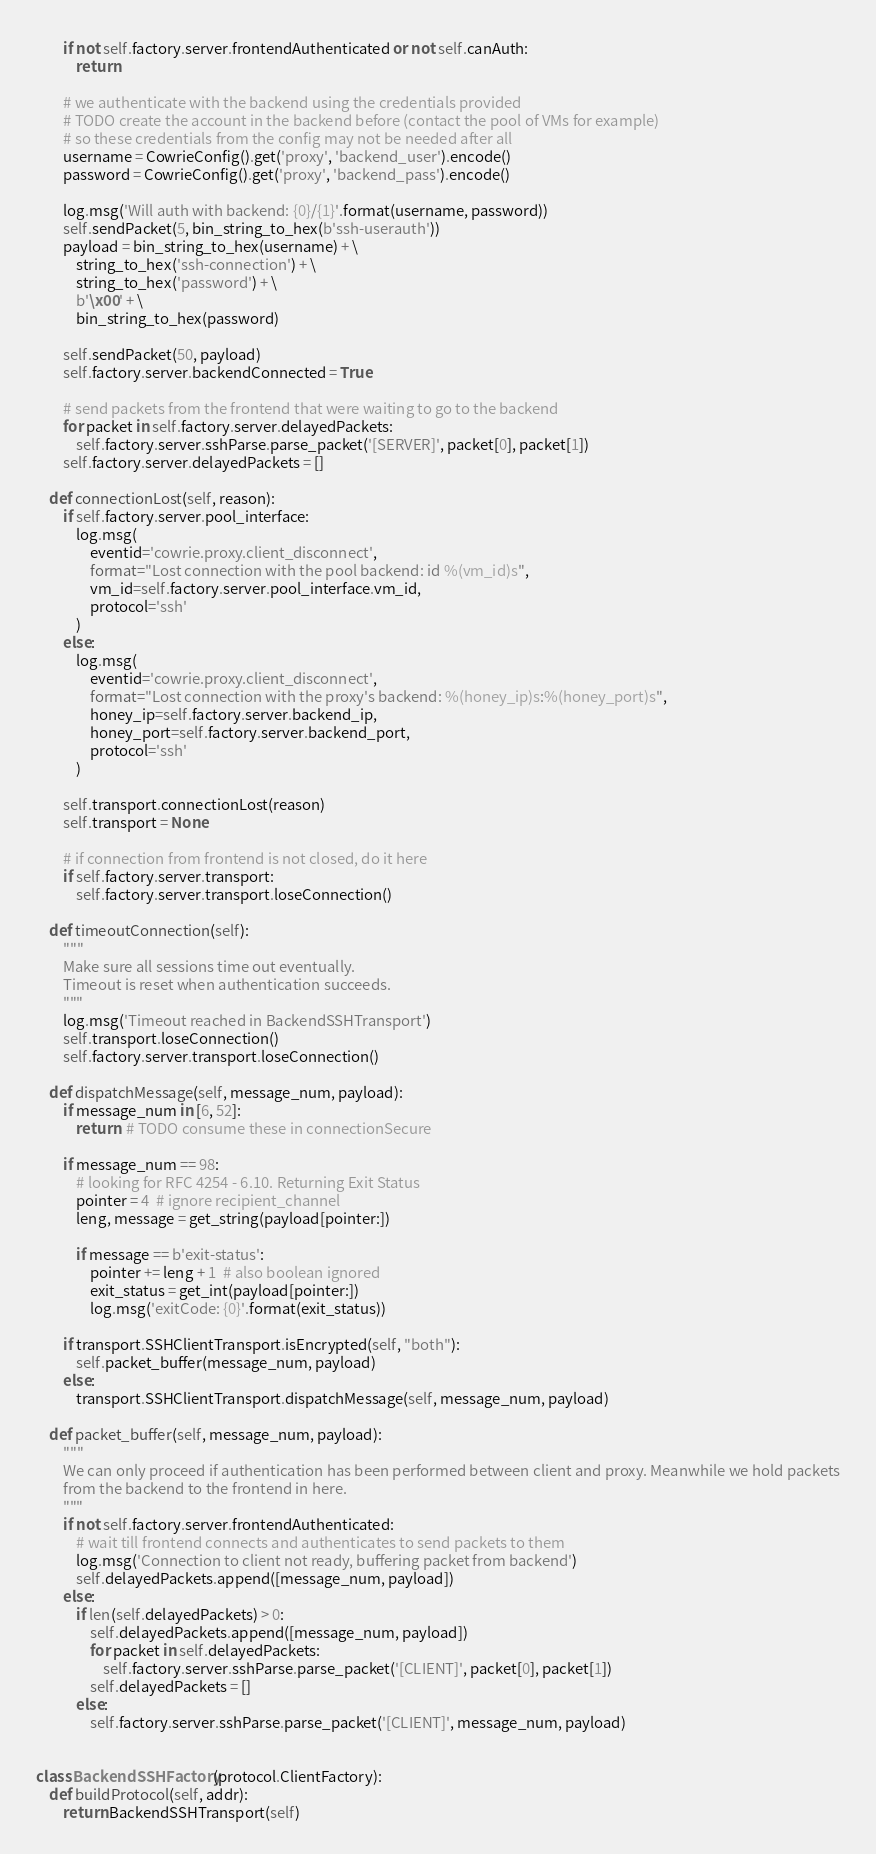Convert code to text. <code><loc_0><loc_0><loc_500><loc_500><_Python_>        if not self.factory.server.frontendAuthenticated or not self.canAuth:
            return

        # we authenticate with the backend using the credentials provided
        # TODO create the account in the backend before (contact the pool of VMs for example)
        # so these credentials from the config may not be needed after all
        username = CowrieConfig().get('proxy', 'backend_user').encode()
        password = CowrieConfig().get('proxy', 'backend_pass').encode()

        log.msg('Will auth with backend: {0}/{1}'.format(username, password))
        self.sendPacket(5, bin_string_to_hex(b'ssh-userauth'))
        payload = bin_string_to_hex(username) + \
            string_to_hex('ssh-connection') + \
            string_to_hex('password') + \
            b'\x00' + \
            bin_string_to_hex(password)

        self.sendPacket(50, payload)
        self.factory.server.backendConnected = True

        # send packets from the frontend that were waiting to go to the backend
        for packet in self.factory.server.delayedPackets:
            self.factory.server.sshParse.parse_packet('[SERVER]', packet[0], packet[1])
        self.factory.server.delayedPackets = []

    def connectionLost(self, reason):
        if self.factory.server.pool_interface:
            log.msg(
                eventid='cowrie.proxy.client_disconnect',
                format="Lost connection with the pool backend: id %(vm_id)s",
                vm_id=self.factory.server.pool_interface.vm_id,
                protocol='ssh'
            )
        else:
            log.msg(
                eventid='cowrie.proxy.client_disconnect',
                format="Lost connection with the proxy's backend: %(honey_ip)s:%(honey_port)s",
                honey_ip=self.factory.server.backend_ip,
                honey_port=self.factory.server.backend_port,
                protocol='ssh'
            )

        self.transport.connectionLost(reason)
        self.transport = None

        # if connection from frontend is not closed, do it here
        if self.factory.server.transport:
            self.factory.server.transport.loseConnection()

    def timeoutConnection(self):
        """
        Make sure all sessions time out eventually.
        Timeout is reset when authentication succeeds.
        """
        log.msg('Timeout reached in BackendSSHTransport')
        self.transport.loseConnection()
        self.factory.server.transport.loseConnection()

    def dispatchMessage(self, message_num, payload):
        if message_num in [6, 52]:
            return  # TODO consume these in connectionSecure

        if message_num == 98:
            # looking for RFC 4254 - 6.10. Returning Exit Status
            pointer = 4  # ignore recipient_channel
            leng, message = get_string(payload[pointer:])

            if message == b'exit-status':
                pointer += leng + 1  # also boolean ignored
                exit_status = get_int(payload[pointer:])
                log.msg('exitCode: {0}'.format(exit_status))

        if transport.SSHClientTransport.isEncrypted(self, "both"):
            self.packet_buffer(message_num, payload)
        else:
            transport.SSHClientTransport.dispatchMessage(self, message_num, payload)

    def packet_buffer(self, message_num, payload):
        """
        We can only proceed if authentication has been performed between client and proxy. Meanwhile we hold packets
        from the backend to the frontend in here.
        """
        if not self.factory.server.frontendAuthenticated:
            # wait till frontend connects and authenticates to send packets to them
            log.msg('Connection to client not ready, buffering packet from backend')
            self.delayedPackets.append([message_num, payload])
        else:
            if len(self.delayedPackets) > 0:
                self.delayedPackets.append([message_num, payload])
                for packet in self.delayedPackets:
                    self.factory.server.sshParse.parse_packet('[CLIENT]', packet[0], packet[1])
                self.delayedPackets = []
            else:
                self.factory.server.sshParse.parse_packet('[CLIENT]', message_num, payload)


class BackendSSHFactory(protocol.ClientFactory):
    def buildProtocol(self, addr):
        return BackendSSHTransport(self)
</code> 